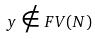<formula> <loc_0><loc_0><loc_500><loc_500>y \notin F V ( N )</formula> 